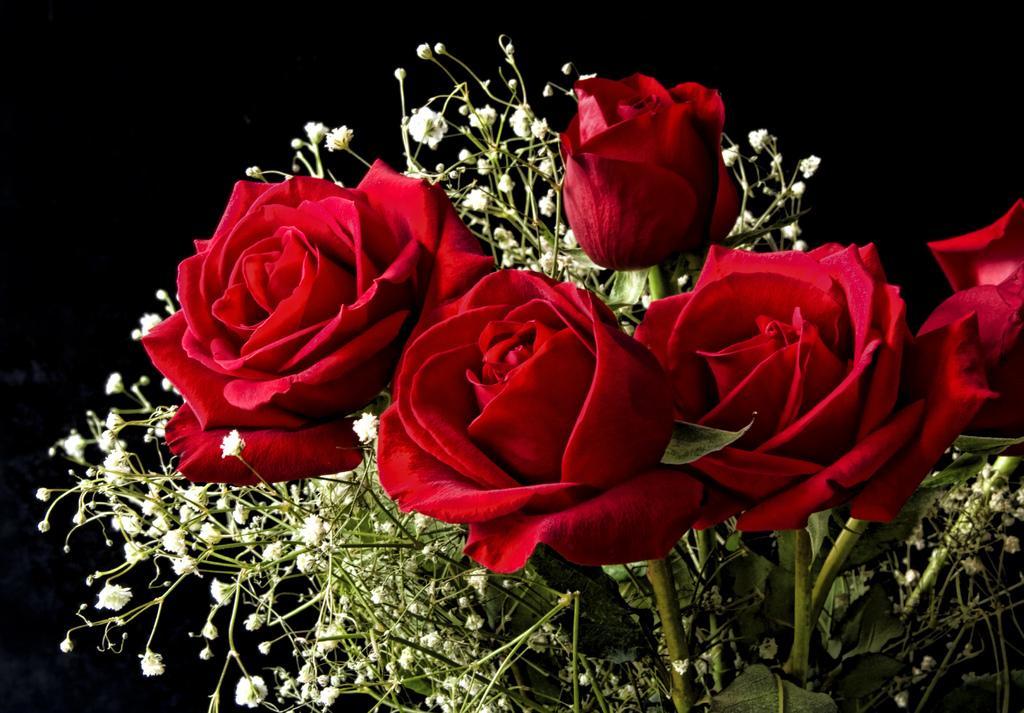Describe this image in one or two sentences. In this image, we can see some red roses. We can also see some tiny flowers and the dark background. 